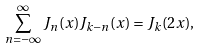Convert formula to latex. <formula><loc_0><loc_0><loc_500><loc_500>\sum _ { n = - \infty } ^ { \infty } J _ { n } ( x ) J _ { k - n } ( x ) = J _ { k } ( 2 x ) ,</formula> 